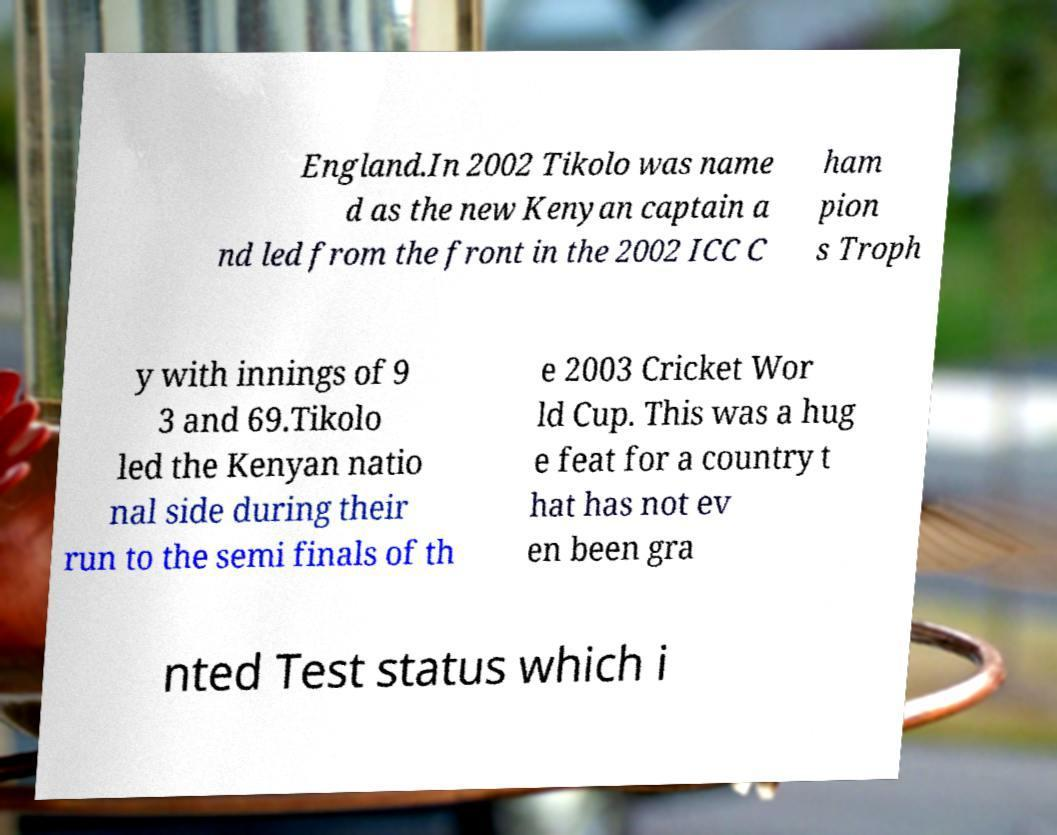What messages or text are displayed in this image? I need them in a readable, typed format. England.In 2002 Tikolo was name d as the new Kenyan captain a nd led from the front in the 2002 ICC C ham pion s Troph y with innings of 9 3 and 69.Tikolo led the Kenyan natio nal side during their run to the semi finals of th e 2003 Cricket Wor ld Cup. This was a hug e feat for a country t hat has not ev en been gra nted Test status which i 